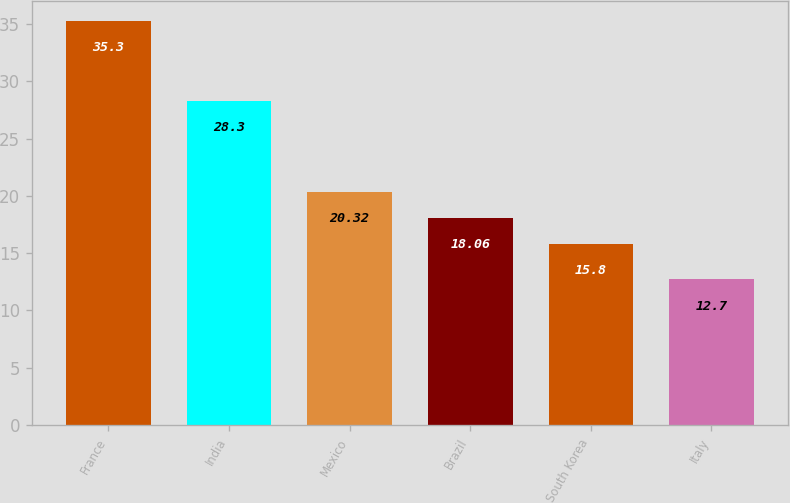Convert chart. <chart><loc_0><loc_0><loc_500><loc_500><bar_chart><fcel>France<fcel>India<fcel>Mexico<fcel>Brazil<fcel>South Korea<fcel>Italy<nl><fcel>35.3<fcel>28.3<fcel>20.32<fcel>18.06<fcel>15.8<fcel>12.7<nl></chart> 